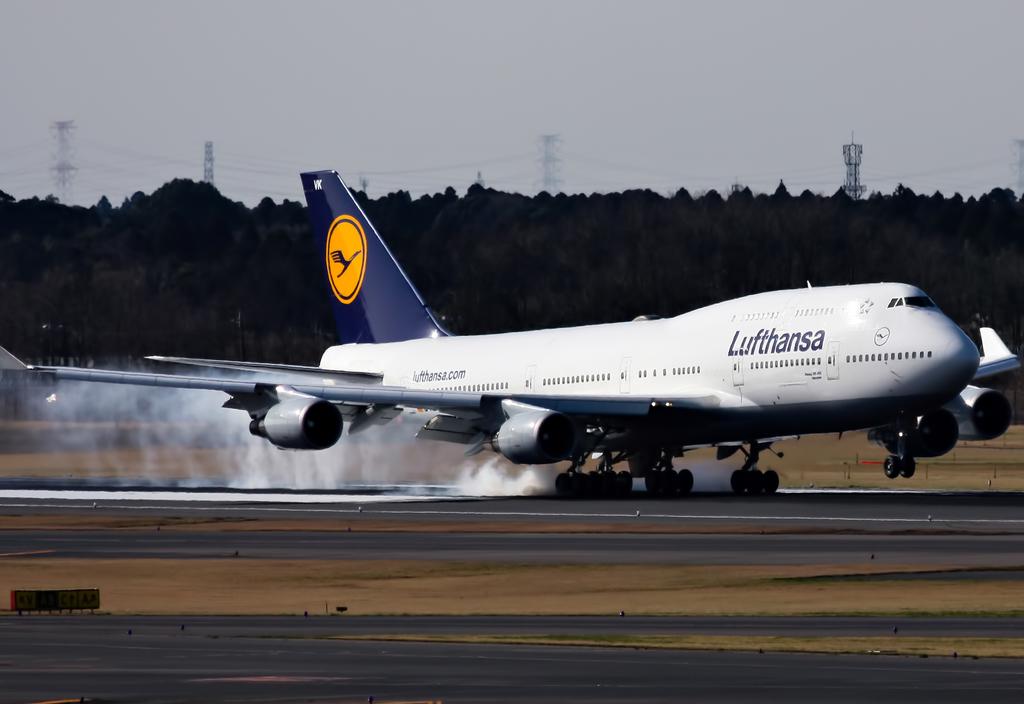What airline is this plane with?
Provide a short and direct response. Lufthansa. 